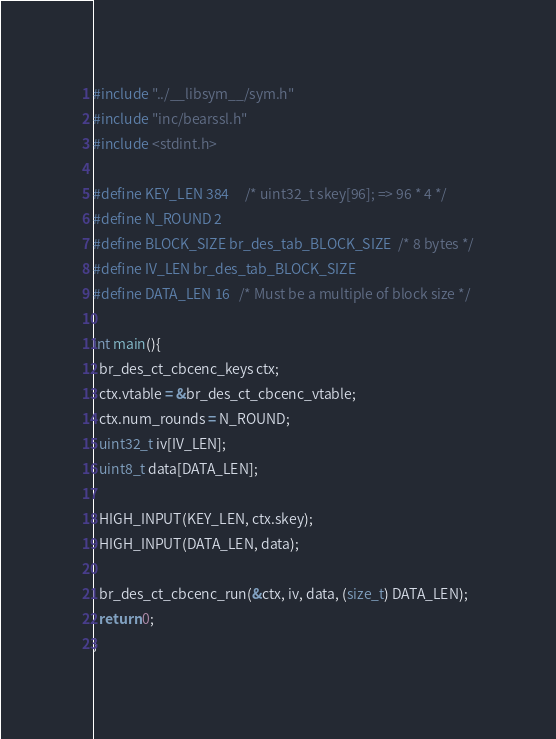<code> <loc_0><loc_0><loc_500><loc_500><_C_>#include "../__libsym__/sym.h"
#include "inc/bearssl.h"
#include <stdint.h>

#define KEY_LEN 384     /* uint32_t skey[96]; => 96 * 4 */
#define N_ROUND 2
#define BLOCK_SIZE br_des_tab_BLOCK_SIZE  /* 8 bytes */
#define IV_LEN br_des_tab_BLOCK_SIZE
#define DATA_LEN 16   /* Must be a multiple of block size */

int main(){  
  br_des_ct_cbcenc_keys ctx;
  ctx.vtable = &br_des_ct_cbcenc_vtable;
  ctx.num_rounds = N_ROUND;
  uint32_t iv[IV_LEN];
  uint8_t data[DATA_LEN];

  HIGH_INPUT(KEY_LEN, ctx.skey);
  HIGH_INPUT(DATA_LEN, data);

  br_des_ct_cbcenc_run(&ctx, iv, data, (size_t) DATA_LEN);
  return 0;
}
</code> 